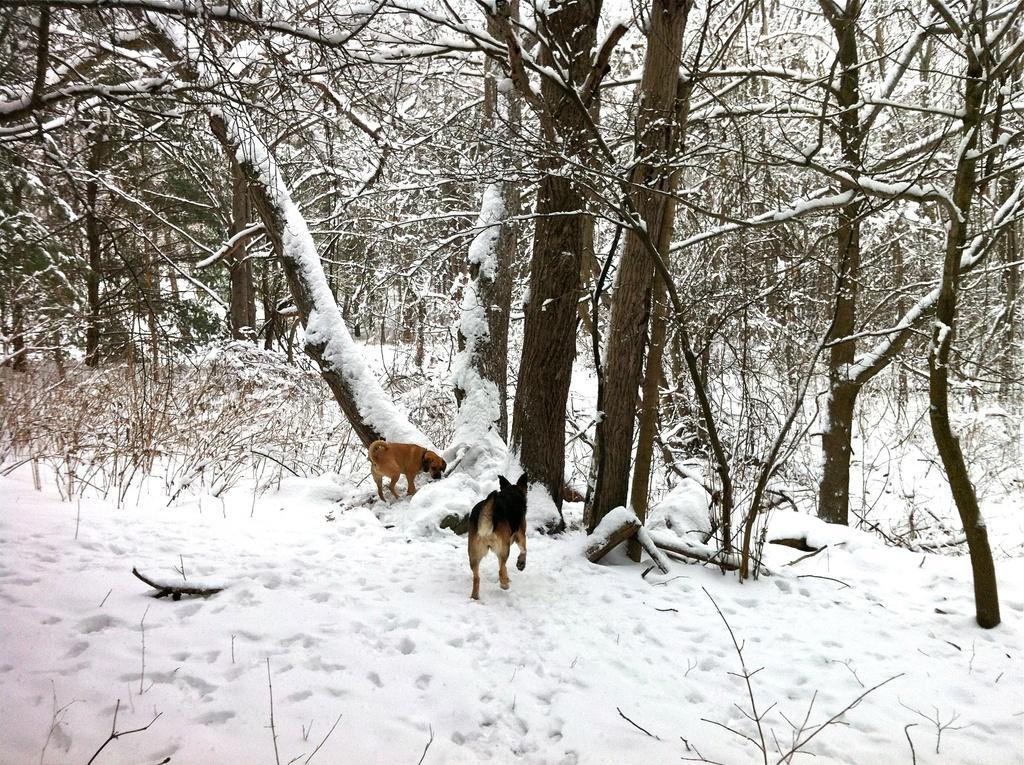In one or two sentences, can you explain what this image depicts? This image is taken outdoors. At the bottom of the image there is snow on the ground. In the middle of the image there are many trees with stems and branches and they are covered with snow. There are a few plants on the ground. There are two dogs on the ground. 